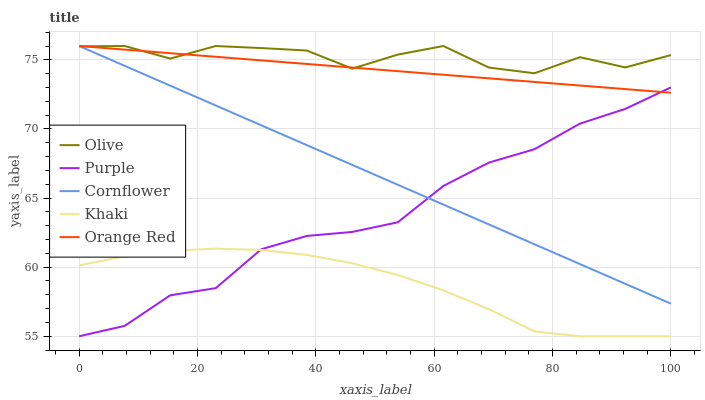Does Khaki have the minimum area under the curve?
Answer yes or no. Yes. Does Olive have the maximum area under the curve?
Answer yes or no. Yes. Does Purple have the minimum area under the curve?
Answer yes or no. No. Does Purple have the maximum area under the curve?
Answer yes or no. No. Is Cornflower the smoothest?
Answer yes or no. Yes. Is Olive the roughest?
Answer yes or no. Yes. Is Purple the smoothest?
Answer yes or no. No. Is Purple the roughest?
Answer yes or no. No. Does Purple have the lowest value?
Answer yes or no. Yes. Does Orange Red have the lowest value?
Answer yes or no. No. Does Cornflower have the highest value?
Answer yes or no. Yes. Does Purple have the highest value?
Answer yes or no. No. Is Khaki less than Cornflower?
Answer yes or no. Yes. Is Orange Red greater than Khaki?
Answer yes or no. Yes. Does Orange Red intersect Purple?
Answer yes or no. Yes. Is Orange Red less than Purple?
Answer yes or no. No. Is Orange Red greater than Purple?
Answer yes or no. No. Does Khaki intersect Cornflower?
Answer yes or no. No. 